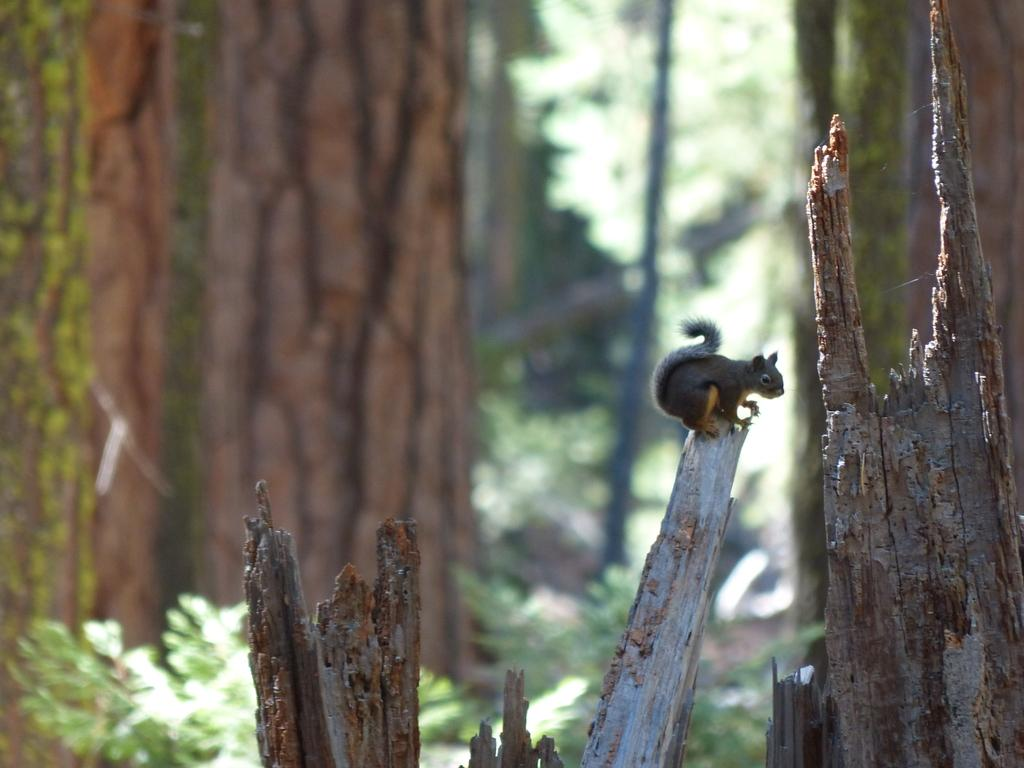What type of objects are in the image? There are wooden pieces in the image. Is there any animal present on the wooden pieces? Yes, there is a squirrel on one of the wooden pieces. What can be seen in the background of the image? The background of the image is blurred, but plants are visible. What type of party is the squirrel attending in the image? There is no party present in the image; it is a squirrel sitting on a wooden piece. How much debt does the squirrel have in the image? There is no mention of debt in the image; it is a squirrel sitting on a wooden piece. 